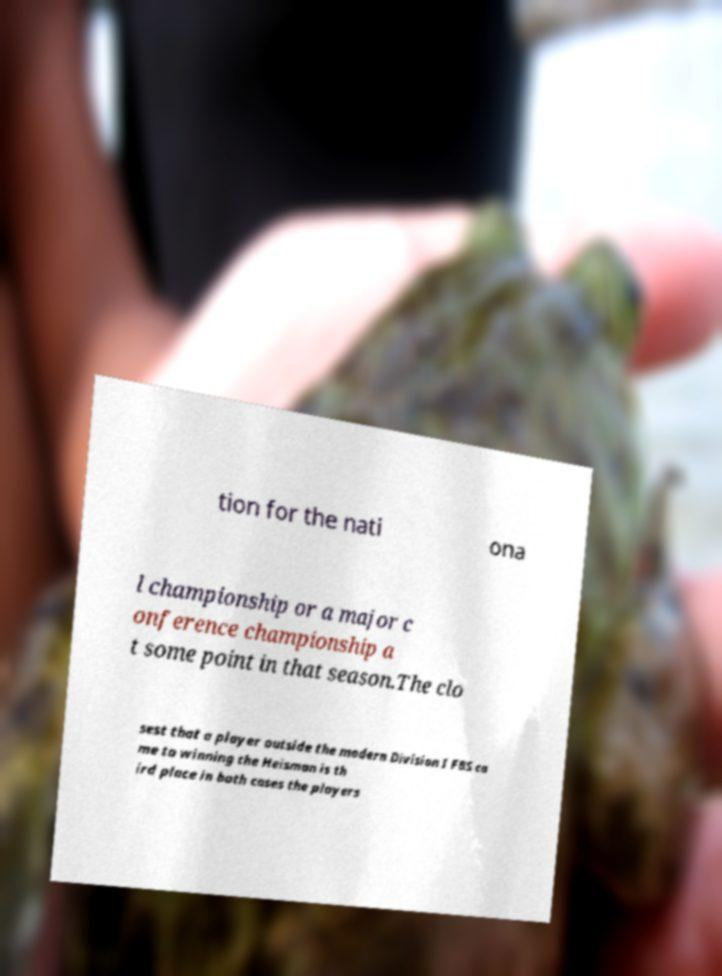I need the written content from this picture converted into text. Can you do that? tion for the nati ona l championship or a major c onference championship a t some point in that season.The clo sest that a player outside the modern Division I FBS ca me to winning the Heisman is th ird place in both cases the players 